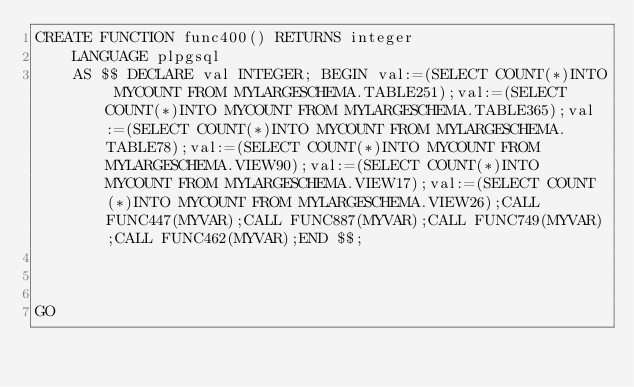Convert code to text. <code><loc_0><loc_0><loc_500><loc_500><_SQL_>CREATE FUNCTION func400() RETURNS integer
    LANGUAGE plpgsql
    AS $$ DECLARE val INTEGER; BEGIN val:=(SELECT COUNT(*)INTO MYCOUNT FROM MYLARGESCHEMA.TABLE251);val:=(SELECT COUNT(*)INTO MYCOUNT FROM MYLARGESCHEMA.TABLE365);val:=(SELECT COUNT(*)INTO MYCOUNT FROM MYLARGESCHEMA.TABLE78);val:=(SELECT COUNT(*)INTO MYCOUNT FROM MYLARGESCHEMA.VIEW90);val:=(SELECT COUNT(*)INTO MYCOUNT FROM MYLARGESCHEMA.VIEW17);val:=(SELECT COUNT(*)INTO MYCOUNT FROM MYLARGESCHEMA.VIEW26);CALL FUNC447(MYVAR);CALL FUNC887(MYVAR);CALL FUNC749(MYVAR);CALL FUNC462(MYVAR);END $$;



GO</code> 